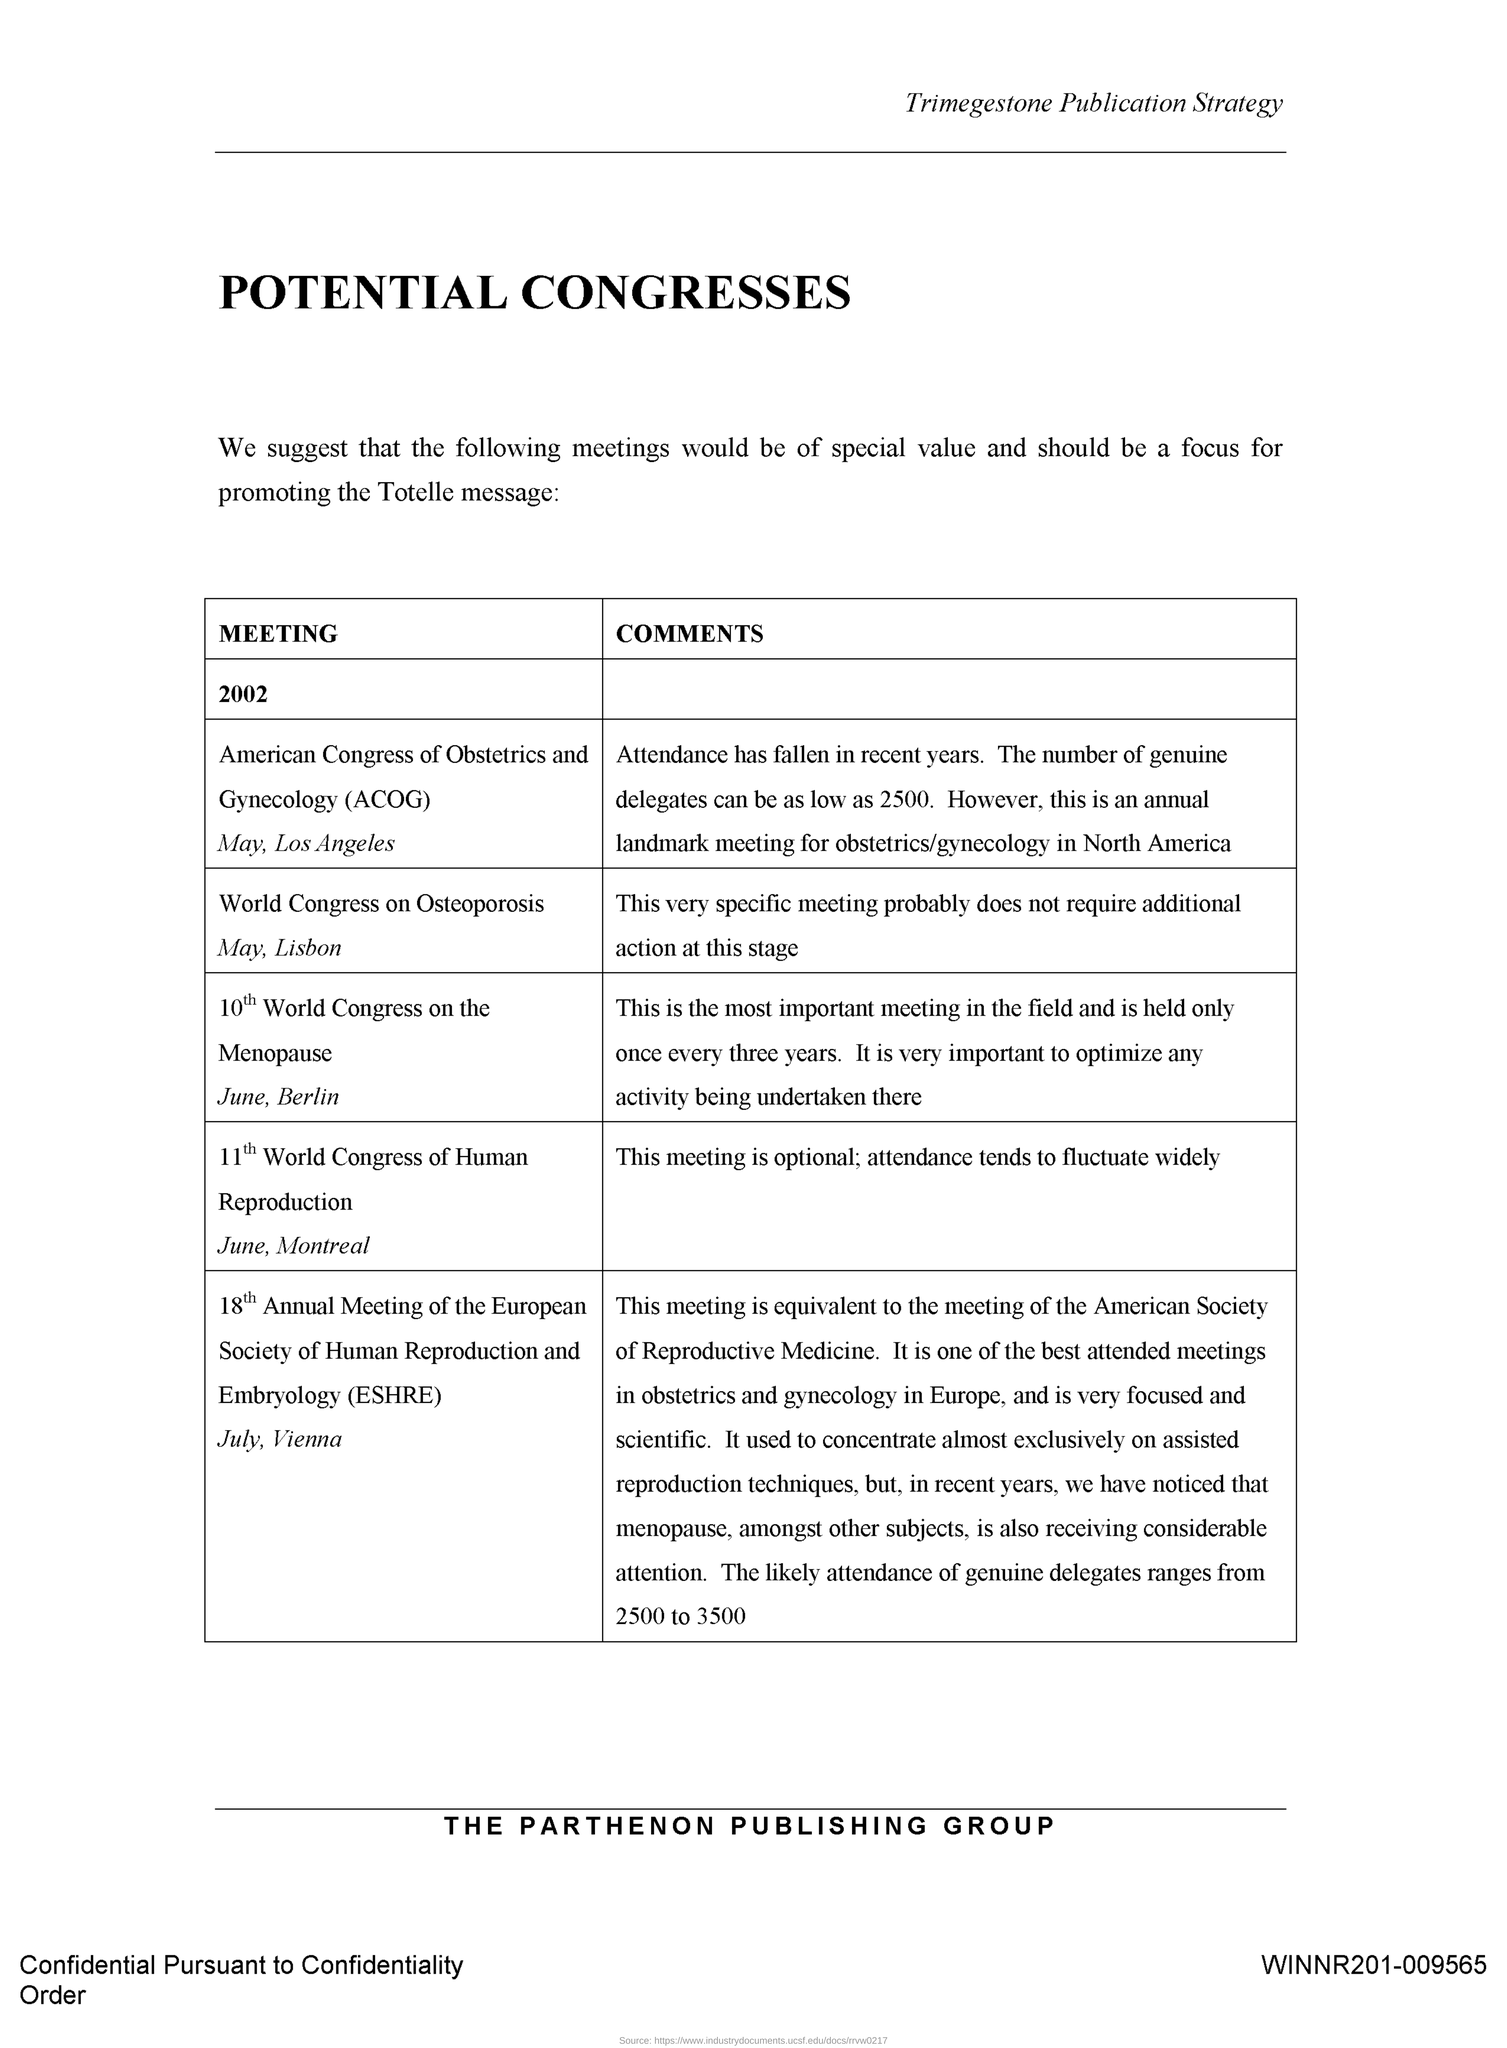Which title is at the header of the document?
Provide a short and direct response. Trimegestone Publication Strategy. Which title is at the footer of the document?
Offer a very short reply. The Parthenon Publishing Group. World Congress on Osteoporosis is on which place?
Provide a succinct answer. Lisbon. 11th World Congress of Human Reproduction is on which place?
Offer a very short reply. Montreal. 